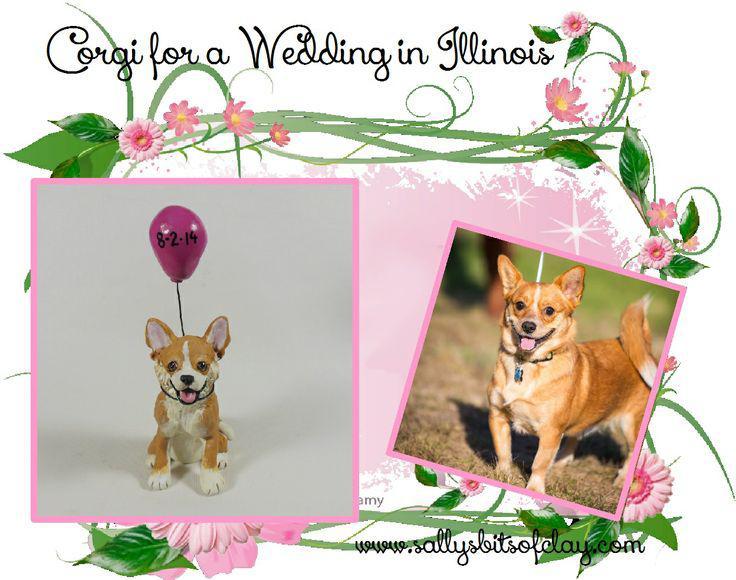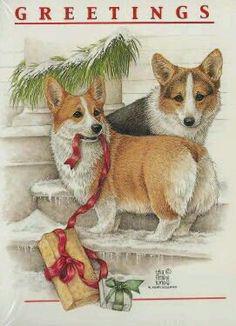The first image is the image on the left, the second image is the image on the right. Considering the images on both sides, is "A corgi wearing a tie around his neck is behind a table with his front paws propped on its edge." valid? Answer yes or no. No. The first image is the image on the left, the second image is the image on the right. Analyze the images presented: Is the assertion "Both images feature the same number of dogs." valid? Answer yes or no. Yes. 